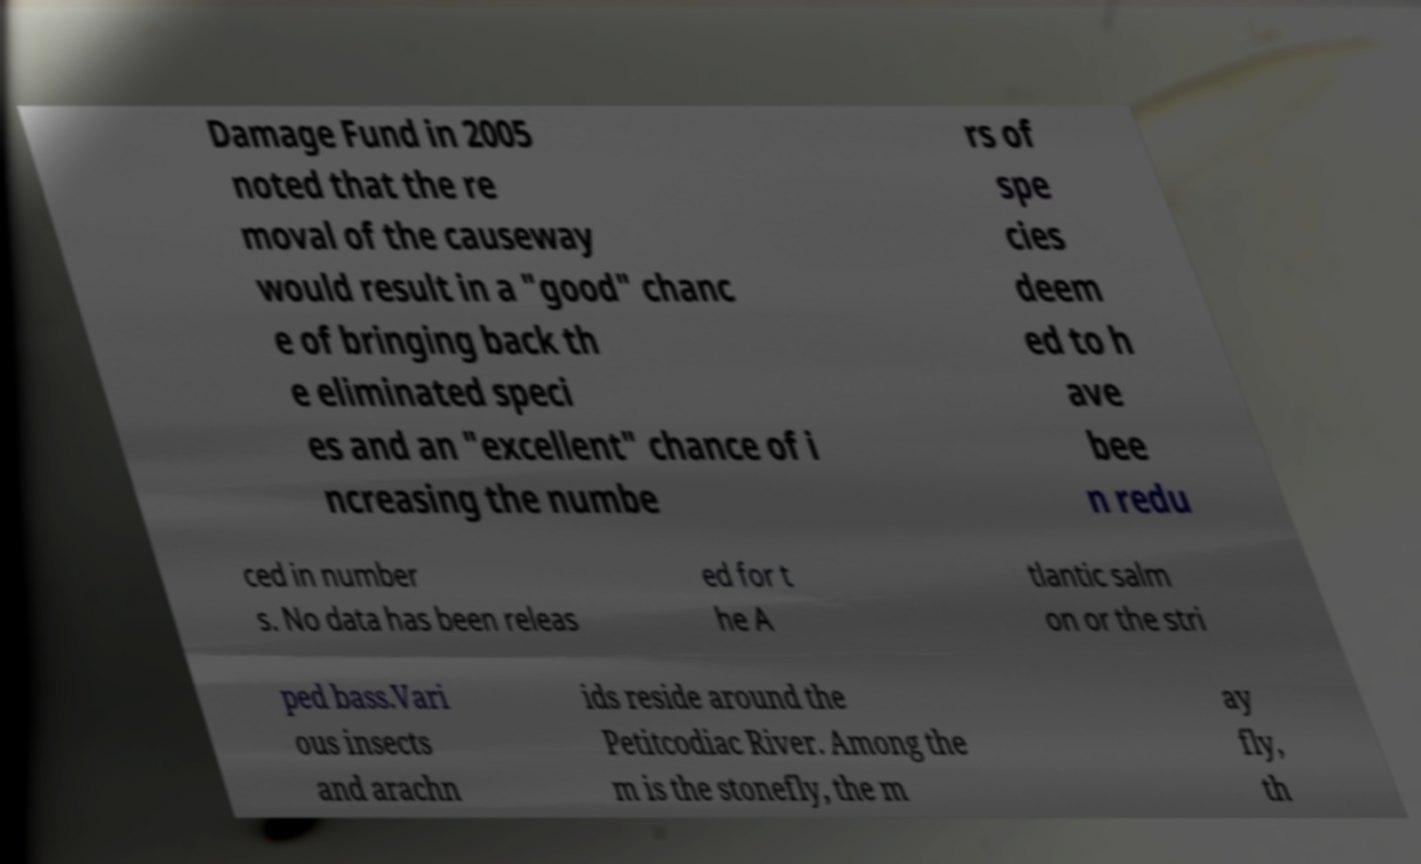Can you read and provide the text displayed in the image?This photo seems to have some interesting text. Can you extract and type it out for me? Damage Fund in 2005 noted that the re moval of the causeway would result in a "good" chanc e of bringing back th e eliminated speci es and an "excellent" chance of i ncreasing the numbe rs of spe cies deem ed to h ave bee n redu ced in number s. No data has been releas ed for t he A tlantic salm on or the stri ped bass.Vari ous insects and arachn ids reside around the Petitcodiac River. Among the m is the stonefly, the m ay fly, th 